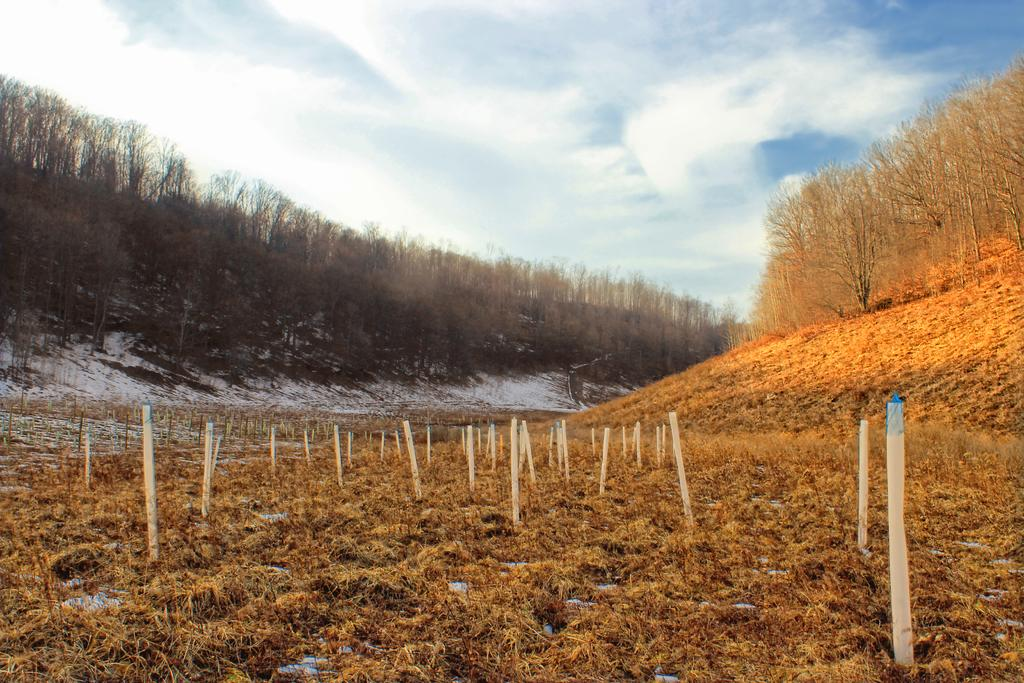What type of vegetation is present in the image? There is dry grass in the image. What structures can be seen in the image? There are wooden poles in the image. What is the weather like in the image? The sky is clear in the image, suggesting a clear day. What is present on the left side of the image? There is snow and trees on the left side of the image. What is present on the right side of the image? There are trees on the right side of the image. What type of nut is being cracked by the writer in the image? There is no writer or nut present in the image. What day of the week is depicted in the image? The day of the week is not mentioned or depicted in the image. 